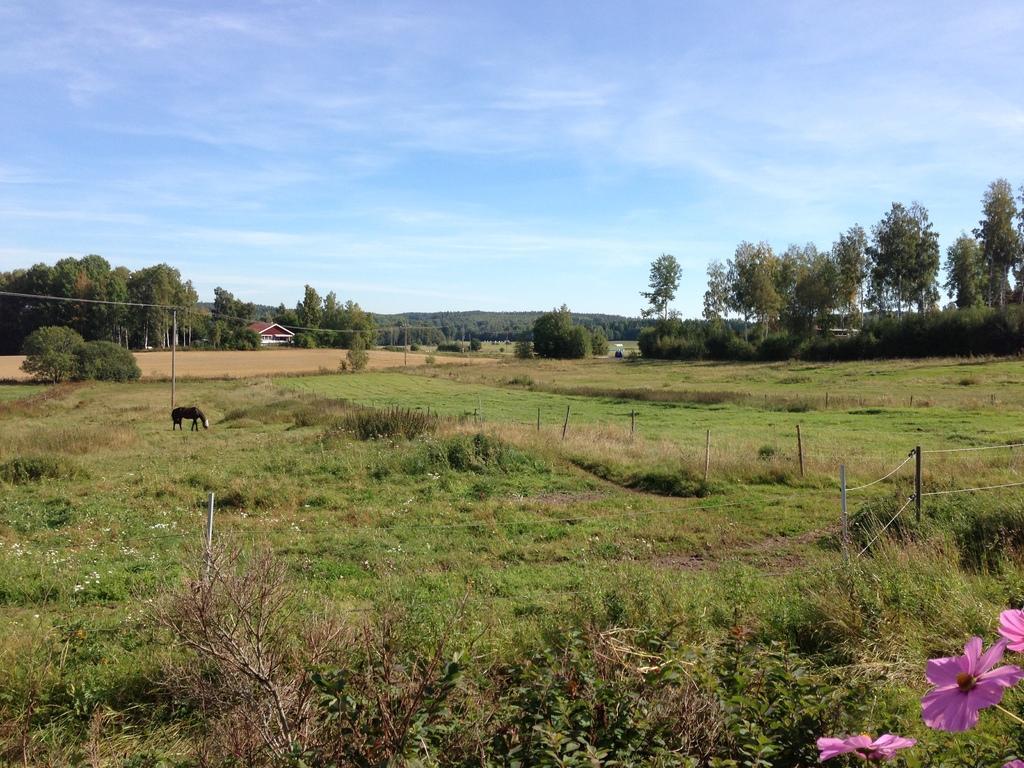Can you describe this image briefly? In this image we can see trees, plants, grass, pole, horse, house, sky and clouds. 